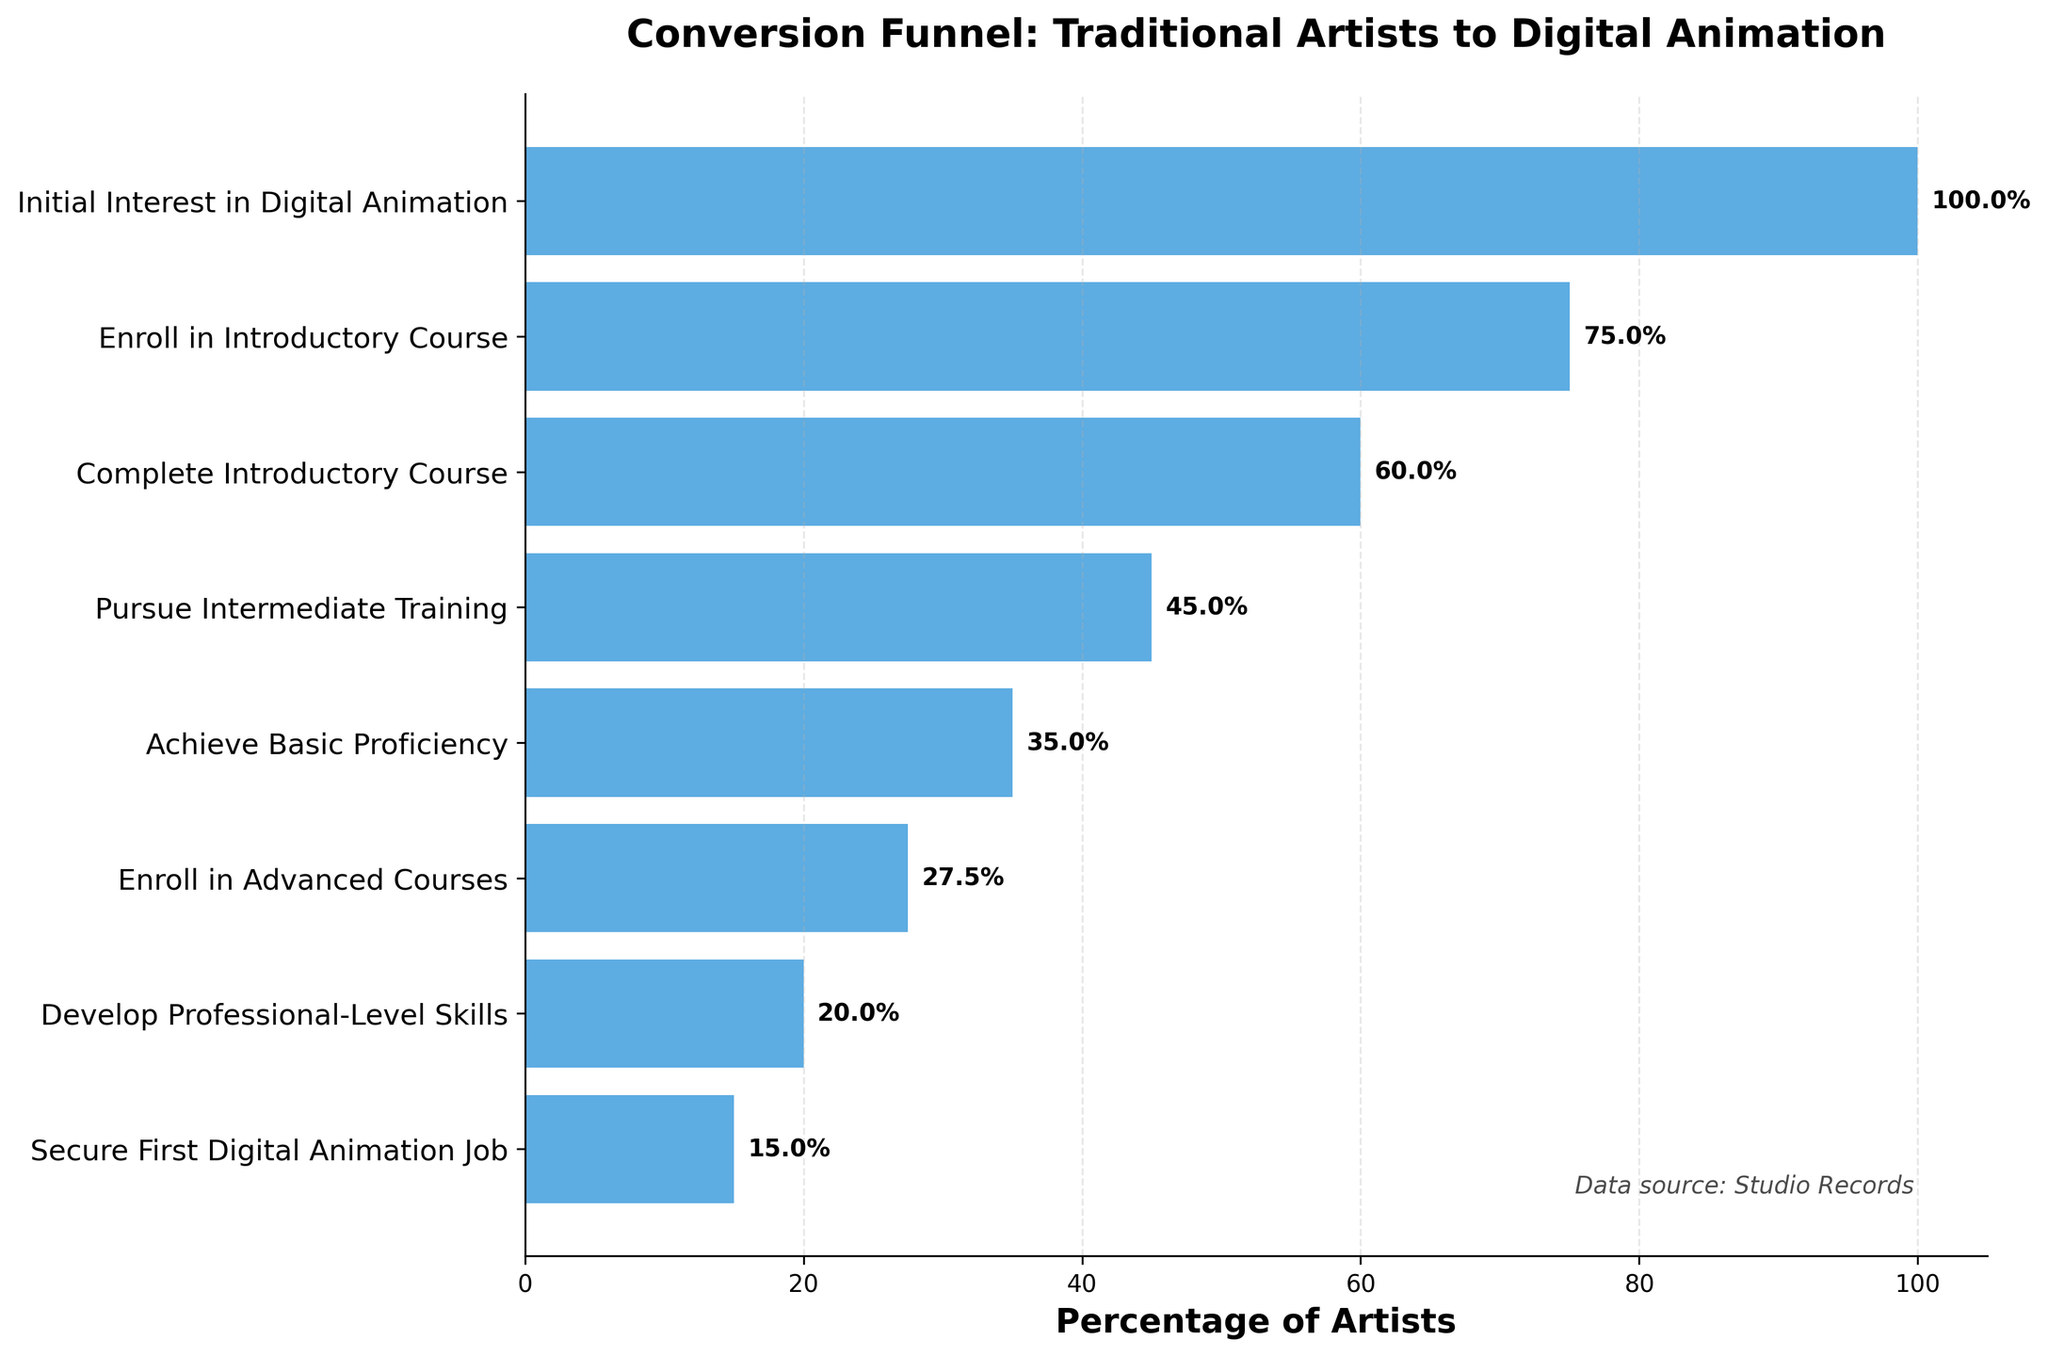What is the title of the figure? The title is usually placed at the top of the figure, and in this case, it reads "Conversion Funnel: Traditional Artists to Digital Animation". This title is directly visible in the provided plot and assists viewers in understanding the central theme of the chart.
Answer: Conversion Funnel: Traditional Artists to Digital Animation What is the percentage of artists who enroll in Introductory Course? To find the percentage of artists who enroll in the introductory course, look at the horizontal bar corresponding to "Enroll in Introductory Course". The percentage label at the end of the bar indicates 75%.
Answer: 75% Which stage has the highest drop-off in the number of artists, and what is the drop-off percentage? To determine the highest drop-off, compare the differences in the number of artists between successive stages. The largest drop-off is between "Pursue Intermediate Training" (450 artists) and "Achieve Basic Proficiency" (350 artists), which is a drop of 100 artists. Calculate the drop-off percentage: (100/450)*100 = 22.2%.
Answer: Pursue Intermediate Training to Achieve Basic Proficiency, 22.2% Compare the percentage of artists who achieve basic proficiency to those who develop professional-level skills. The percentage of artists achieving basic proficiency is 35%, and those developing professional-level skills is 20%. A comparison shows that almost twice as many artists achieve basic proficiency compared to those who develop professional-level skills.
Answer: Achieve Basic Proficiency is 35%, Develop Professional-Level Skills is 20% What is the sequence of stages for the artists from initial interest to securing the first digital animation job? Reading the y-axis labels from top to bottom will provide the sequence of stages: Initial Interest in Digital Animation, Enroll in Introductory Course, Complete Introductory Course, Pursue Intermediate Training, Achieve Basic Proficiency, Enroll in Advanced Courses, Develop Professional-Level Skills, Secure First Digital Animation Job.
Answer: Initial Interest → Enroll in Introductory Course → Complete Introductory Course → Pursue Intermediate Training → Achieve Basic Proficiency → Enroll in Advanced Courses → Develop Professional-Level Skills → Secure First Digital Animation Job By what percentage do artists decrease from those who complete the introductory course to those who pursue intermediate training? The number of artists who complete the introductory course is 600, and those who pursue intermediate training is 450. The decrease is 600 - 450 = 150 artists. Calculate the percentage decrease: (150/600)*100 = 25%.
Answer: 25% What is the total number of artists who reach at least the stage of achieving basic proficiency? To find this, sum the number of artists from the stage "Achieve Basic Proficiency" onwards: 350 (Achieve Basic Proficiency) + 275 (Enroll in Advanced Courses) + 200 (Develop Professional-Level Skills) + 150 (Secure First Digital Animation Job). This gives a total of 975 artists.
Answer: 975 